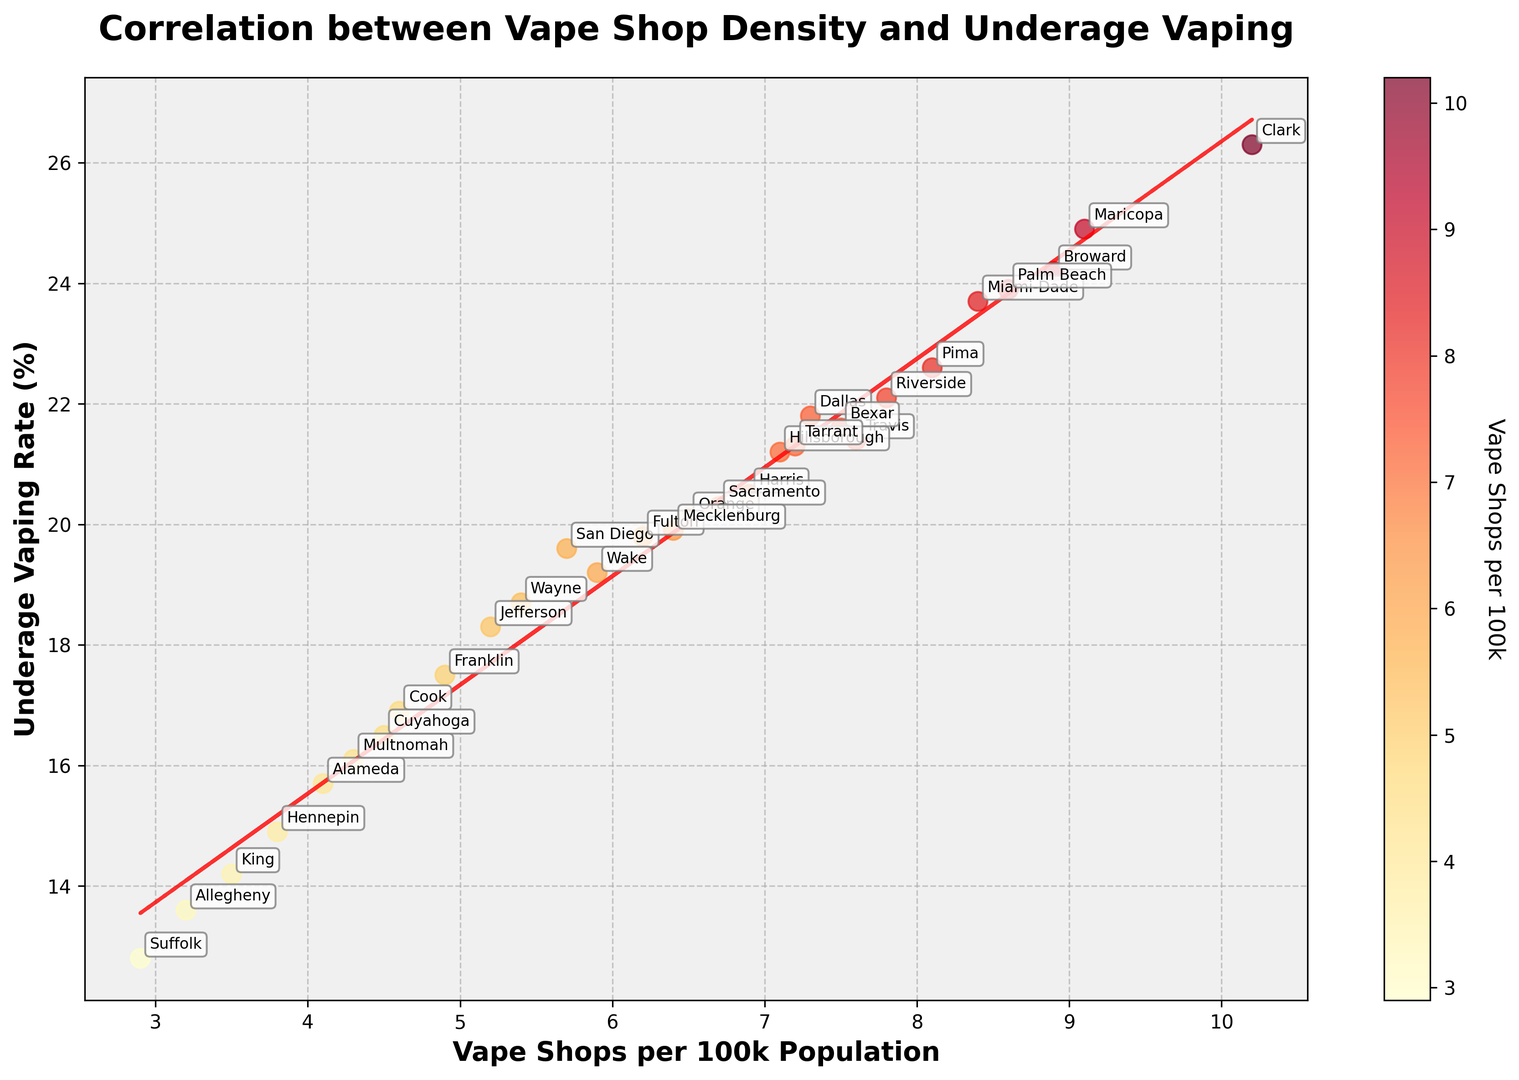Which county has the highest underage vaping rate? By examining the y-axis which represents the underage vaping rate, Maricopa County has the highest rate with approximately 26.3%.
Answer: Maricopa How many counties have an underage vaping rate above 20%? By visually inspecting the scatter plot, counties with rates above the 20% line are Riverside, Harris, Miami-Dade, Maricopa, Dallas, Orange, Clark, Broward, Fulton, Sacramento, Pima, Hillsborough, Mecklenburg, Palm Beach, and Tarrant. There are 15 counties in total.
Answer: 15 What is the median number of vape shops per 100k population? To find the median, we need to organize the vape shops per 100k population values in ascending order and find the middle number. After sorting: 2.9, 3.2, 3.5, 3.8, 4.1, 4.3, 4.5, 4.6, 4.9, 5.2, 5.4, 5.7, 5.9, 6.2, 6.4, 6.5, 6.7, 6.9, 7.1, 7.2, 7.3, 7.5, 7.6, 7.8, 8.1, 8.4, 8.6, 8.9, 9.1, 10.2. The median is the middle value, which is 6.5.
Answer: 6.5 Is there a positive correlation between vape shop density and underage vaping rates? By looking at the overall trend and the red dashed line representing the trend, it can be observed that as the number of vape shops per 100k increases, the underage vaping rate also increases. This suggests a positive correlation.
Answer: Yes Which counties have a lower underage vaping rate compared to their vape shops per capita? Counties below the trend line have lower underage vaping rates compared to their vape shops per capita. These include Jefferson, Cook, King, Suffolk, Alameda, Hennepin, Wayne, Franklin, Allegheny, Multnomah, Wake, and Cuyahoga.
Answer: Jefferson, Cook, King, Suffolk, Alameda, Hennepin, Wayne, Franklin, Allegheny, Multnomah, Wake, Cuyahoga 